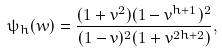<formula> <loc_0><loc_0><loc_500><loc_500>\psi _ { h } ( w ) = \frac { ( 1 + v ^ { 2 } ) ( 1 - v ^ { h + 1 } ) ^ { 2 } } { ( 1 - v ) ^ { 2 } ( 1 + v ^ { 2 h + 2 } ) } ,</formula> 